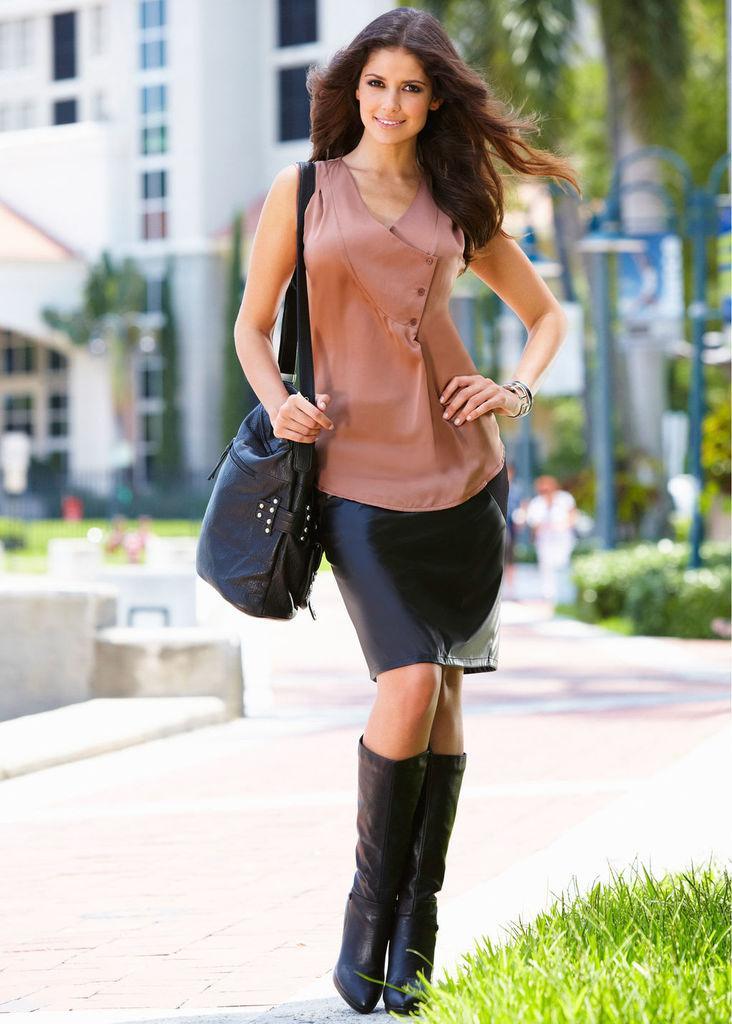In one or two sentences, can you explain what this image depicts? In this image i,n the foreground there is a woman standing and wearing black bag, at the bottom right hand corner we can see grass, background is the sky. 